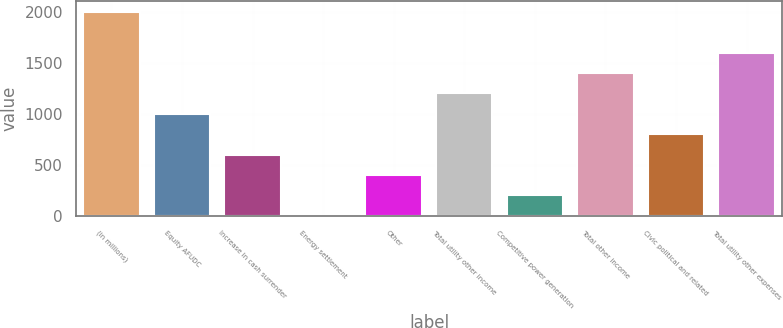Convert chart to OTSL. <chart><loc_0><loc_0><loc_500><loc_500><bar_chart><fcel>(in millions)<fcel>Equity AFUDC<fcel>Increase in cash surrender<fcel>Energy settlement<fcel>Other<fcel>Total utility other income<fcel>Competitive power generation<fcel>Total other income<fcel>Civic political and related<fcel>Total utility other expenses<nl><fcel>2008<fcel>1005.5<fcel>604.5<fcel>3<fcel>404<fcel>1206<fcel>203.5<fcel>1406.5<fcel>805<fcel>1607<nl></chart> 